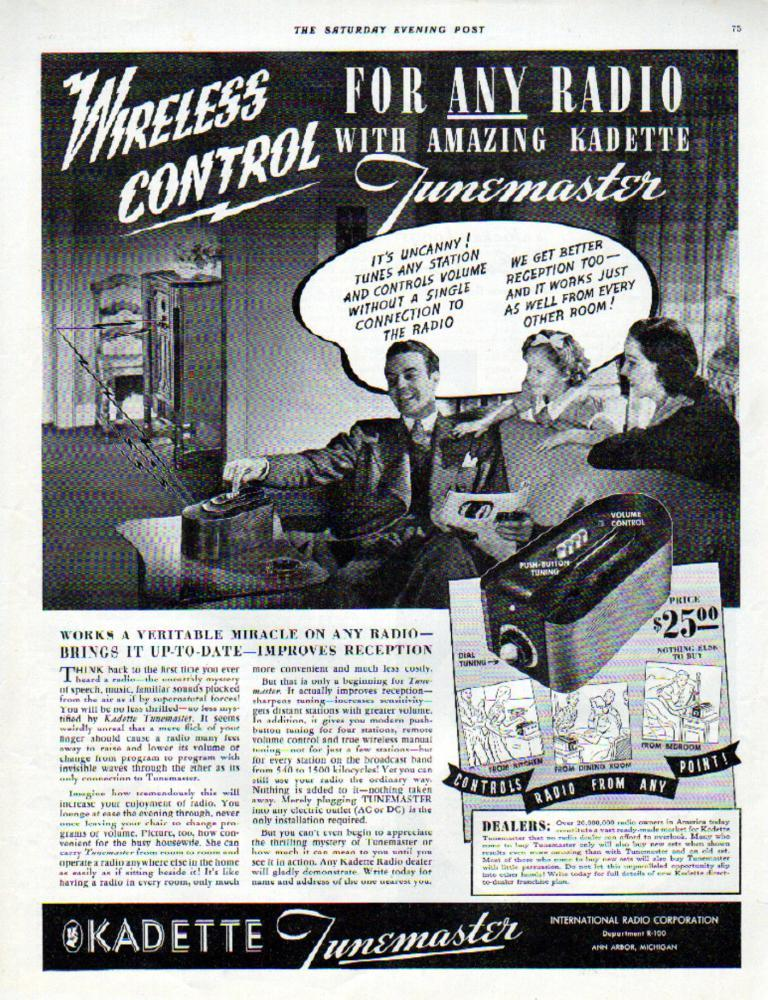What is present on the poster in the image? The poster contains text and images. Can you describe the content of the poster? The poster contains text and images, but the specific content cannot be determined from the provided facts. What type of cakes are being sold at the place depicted in the poster? There is no place or cakes mentioned in the image; the poster only contains text and images. 